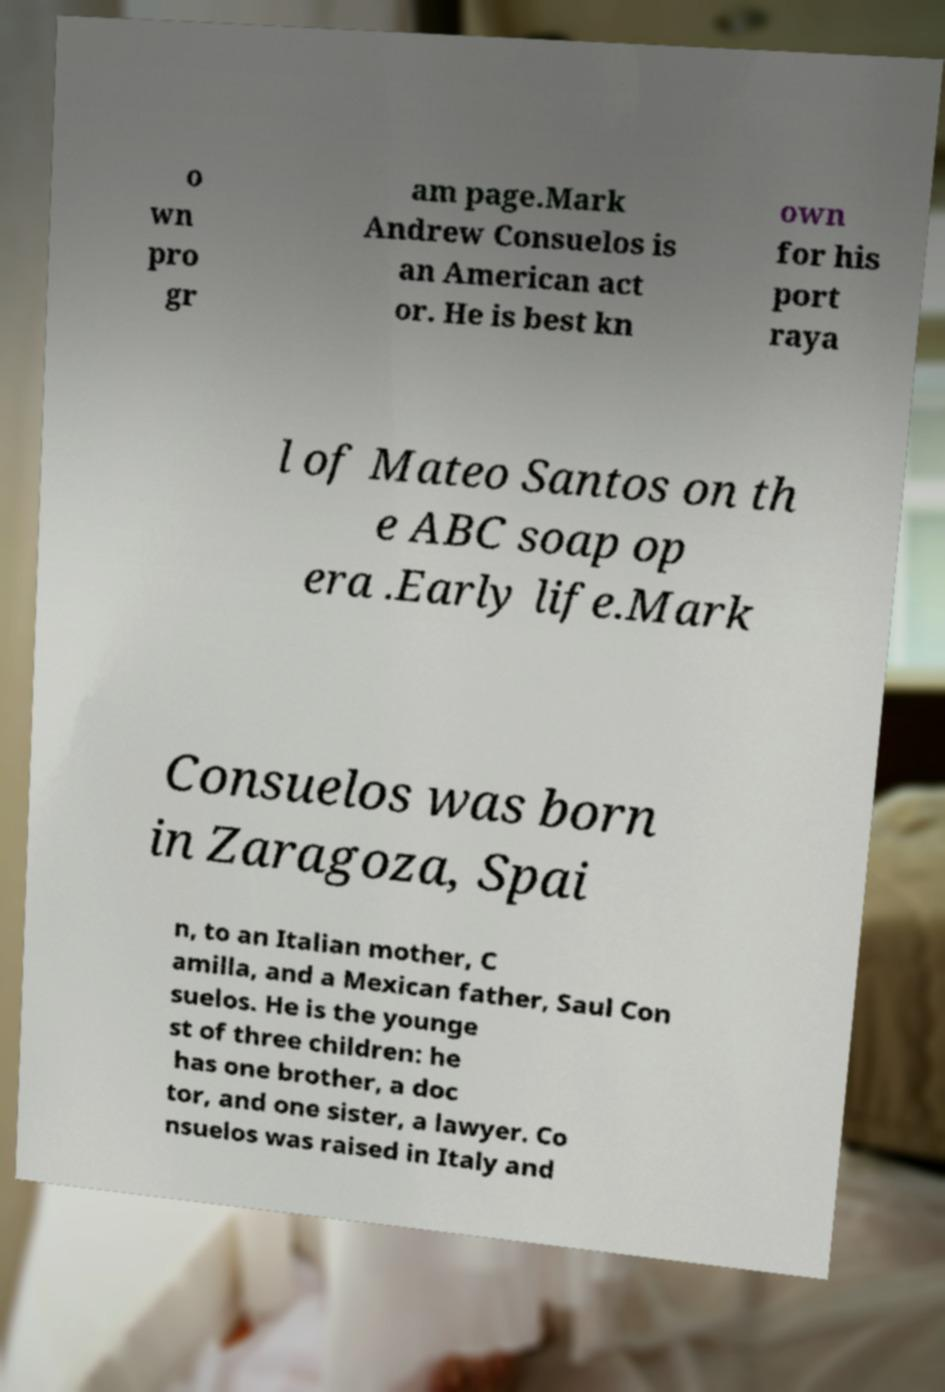Please identify and transcribe the text found in this image. o wn pro gr am page.Mark Andrew Consuelos is an American act or. He is best kn own for his port raya l of Mateo Santos on th e ABC soap op era .Early life.Mark Consuelos was born in Zaragoza, Spai n, to an Italian mother, C amilla, and a Mexican father, Saul Con suelos. He is the younge st of three children: he has one brother, a doc tor, and one sister, a lawyer. Co nsuelos was raised in Italy and 